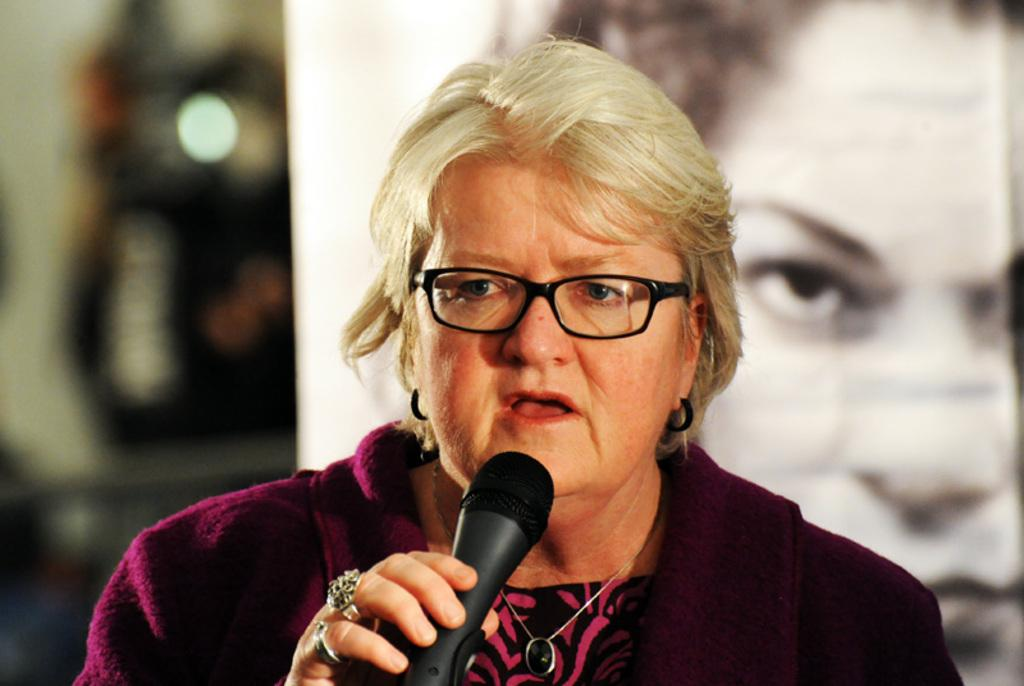Who is the main subject in the image? There is a woman in the image. What is the woman holding in the image? The woman is holding a microphone. What type of eyewear is the woman wearing? The woman is wearing wire spectacles. Can you describe the background of the image? The background of the image is blurry. Are there any other people visible in the image? Yes, a person's face is visible in the background. What type of pipe is visible in the image, and is it emitting steam? There is no pipe or steam present in the image. Is the woman in the image a writer, and is she holding a pen? There is no indication in the image that the woman is a writer, nor is she holding a pen. 